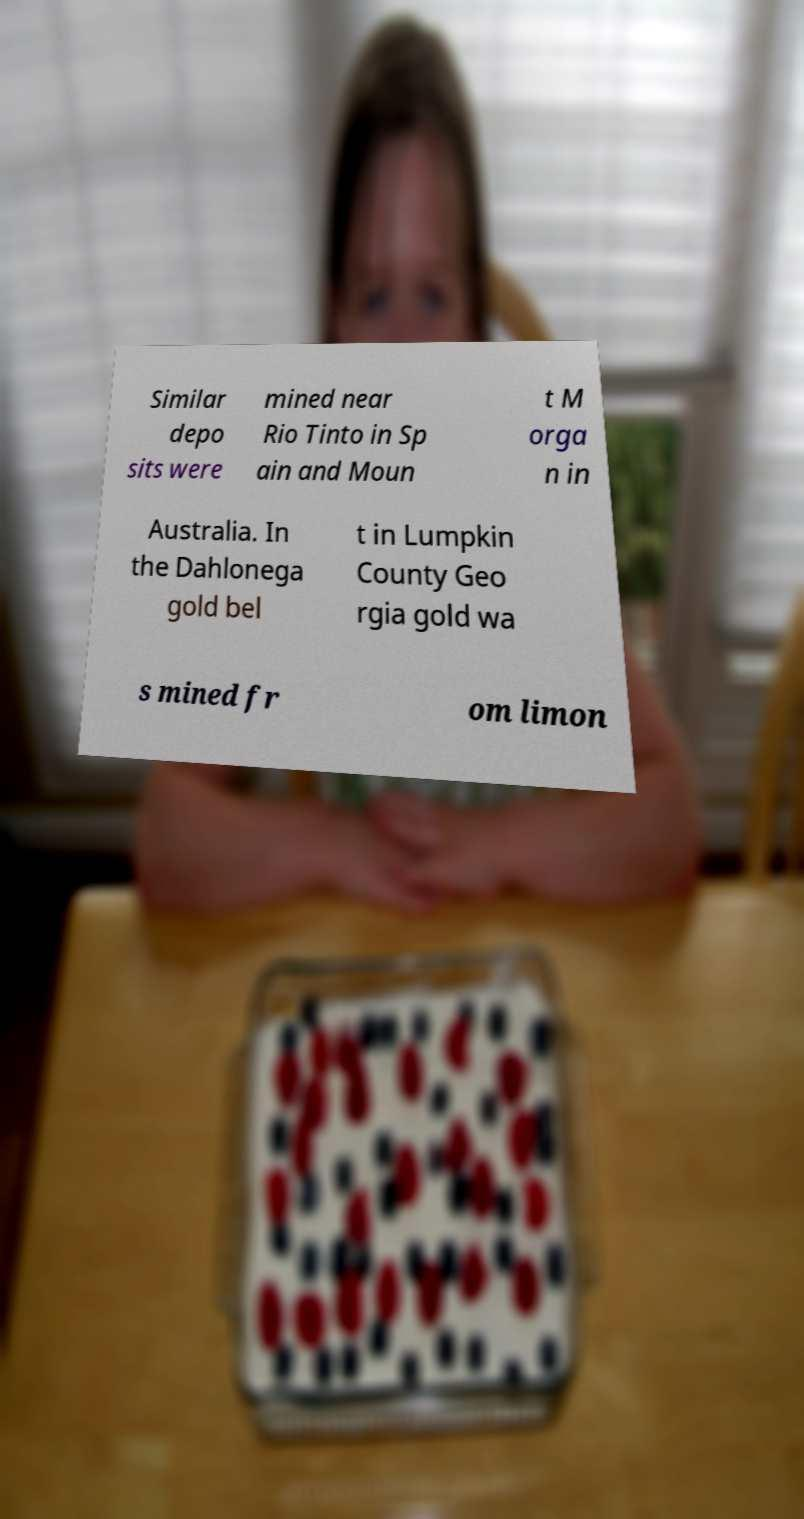I need the written content from this picture converted into text. Can you do that? Similar depo sits were mined near Rio Tinto in Sp ain and Moun t M orga n in Australia. In the Dahlonega gold bel t in Lumpkin County Geo rgia gold wa s mined fr om limon 